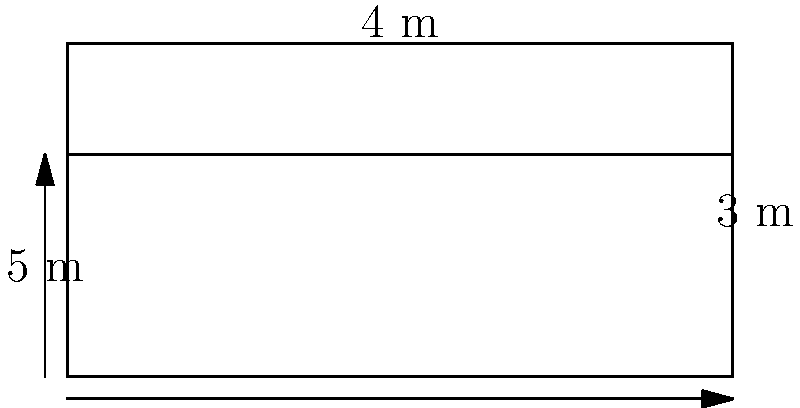A fire truck's water tank has the shape of a rectangular prism. The tank measures 5 meters in length, 4 meters in width, and 3 meters in height. However, to allow for expansion and prevent overflow, the tank is only filled to 2/3 of its total height. Calculate the volume of water, in cubic meters, that can be safely carried in this tank. To solve this problem, we'll follow these steps:

1) First, let's calculate the total volume of the tank:
   $$ V_{total} = length \times width \times height $$
   $$ V_{total} = 5 \text{ m} \times 4 \text{ m} \times 3 \text{ m} = 60 \text{ m}^3 $$

2) However, we're only filling the tank to 2/3 of its height. So we need to calculate 2/3 of the total volume:
   $$ V_{filled} = \frac{2}{3} \times V_{total} $$
   $$ V_{filled} = \frac{2}{3} \times 60 \text{ m}^3 = 40 \text{ m}^3 $$

3) Alternatively, we could have calculated this by using 2/3 of the height in our initial calculation:
   $$ V_{filled} = 5 \text{ m} \times 4 \text{ m} \times (2/3 \times 3 \text{ m}) = 5 \text{ m} \times 4 \text{ m} \times 2 \text{ m} = 40 \text{ m}^3 $$

Therefore, the fire truck can safely carry 40 cubic meters of water.
Answer: 40 m³ 